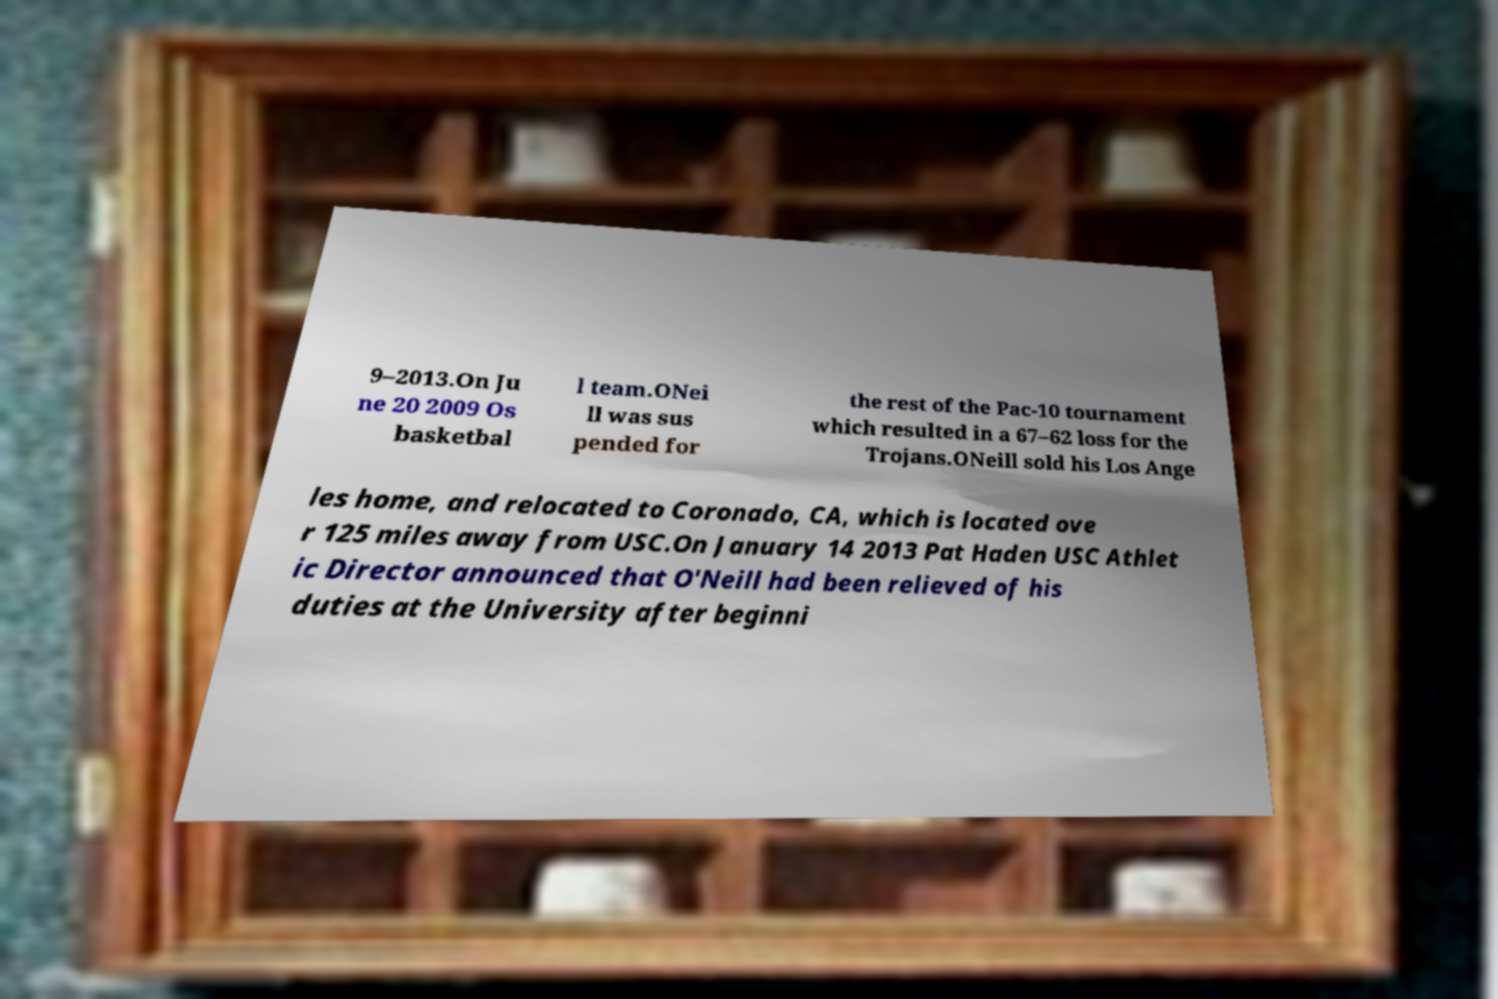For documentation purposes, I need the text within this image transcribed. Could you provide that? 9–2013.On Ju ne 20 2009 Os basketbal l team.ONei ll was sus pended for the rest of the Pac-10 tournament which resulted in a 67–62 loss for the Trojans.ONeill sold his Los Ange les home, and relocated to Coronado, CA, which is located ove r 125 miles away from USC.On January 14 2013 Pat Haden USC Athlet ic Director announced that O'Neill had been relieved of his duties at the University after beginni 